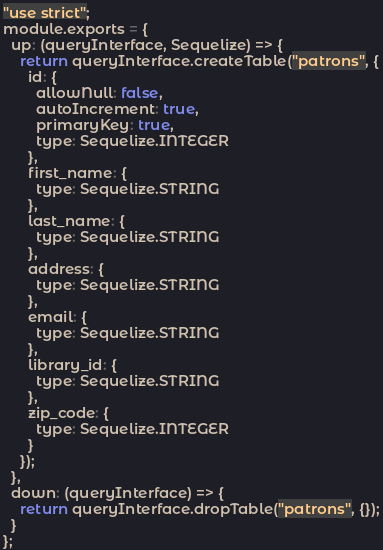<code> <loc_0><loc_0><loc_500><loc_500><_JavaScript_>"use strict";
module.exports = {
  up: (queryInterface, Sequelize) => {
    return queryInterface.createTable("patrons", {
      id: {
        allowNull: false,
        autoIncrement: true,
        primaryKey: true,
        type: Sequelize.INTEGER
      },
      first_name: {
        type: Sequelize.STRING
      },
      last_name: {
        type: Sequelize.STRING
      },
      address: {
        type: Sequelize.STRING
      },
      email: {
        type: Sequelize.STRING
      },
      library_id: {
        type: Sequelize.STRING
      },
      zip_code: {
        type: Sequelize.INTEGER
      }
    });
  },
  down: (queryInterface) => {
    return queryInterface.dropTable("patrons", {});
  }
};
</code> 